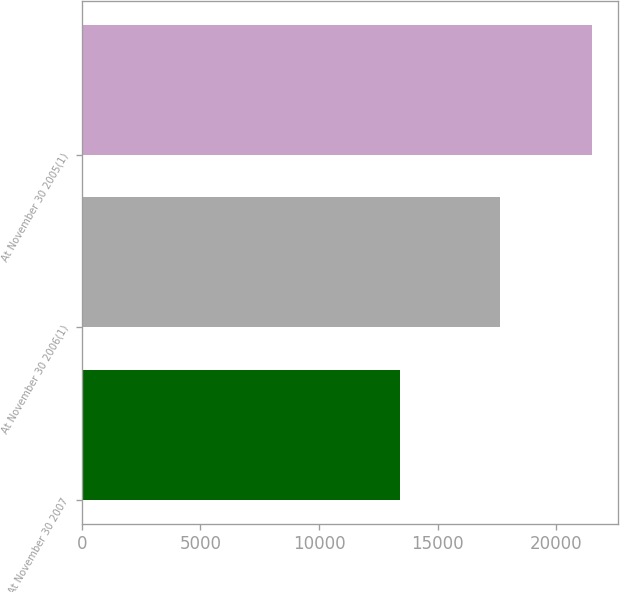Convert chart. <chart><loc_0><loc_0><loc_500><loc_500><bar_chart><fcel>At November 30 2007<fcel>At November 30 2006(1)<fcel>At November 30 2005(1)<nl><fcel>13400<fcel>17631<fcel>21520<nl></chart> 